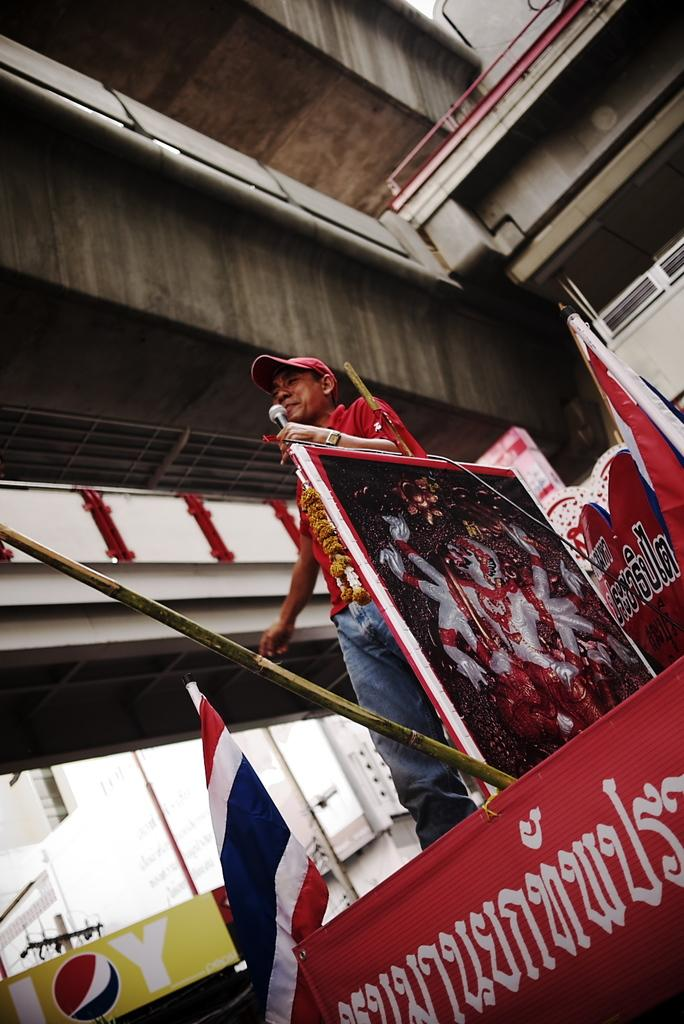What is the person in the image doing? The person is standing in the image and holding a microphone. What else can be seen in the image besides the person? There are posters, flags, a bridge, and buildings in the image. Can you describe the posters and flags in the image? The posters and flags are not described in the provided facts, so we cannot provide specific details about them. What type of payment is being made in the image? There is no indication of any payment being made in the image. Can you describe the sun's position in the image? The provided facts do not mention the sun, so we cannot describe its position in the image. 